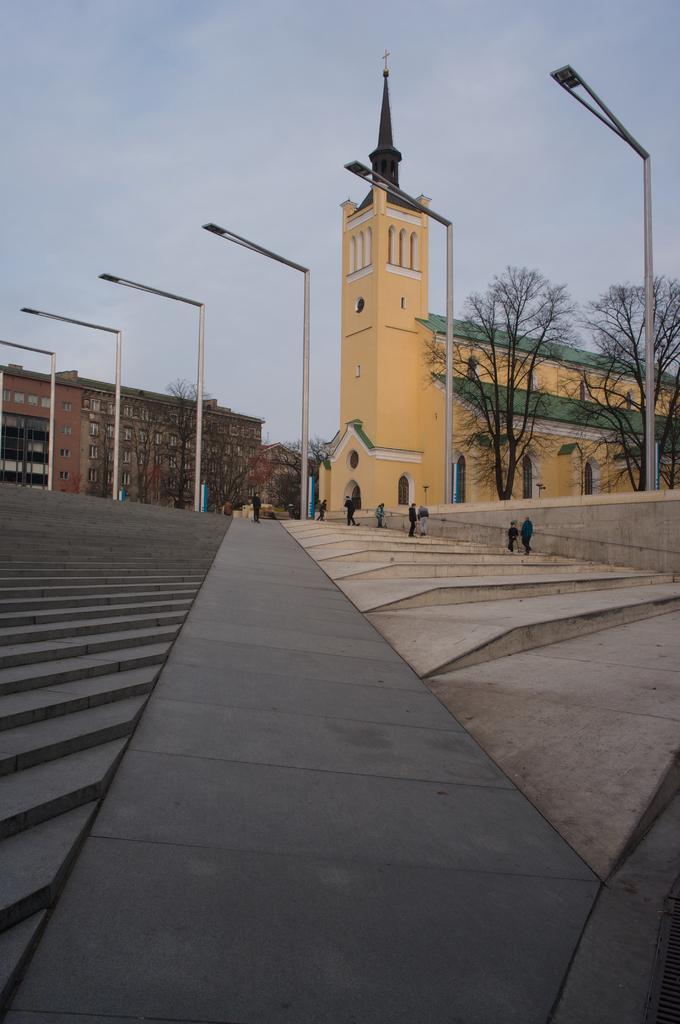In one or two sentences, can you explain what this image depicts? This is an outside view. At the bottom there is a path. On both sides there are stairs. Here I can see few people are climbing the stairs. In the background there are many trees, buildings and light poles. At the top of the image I can see the sky. 